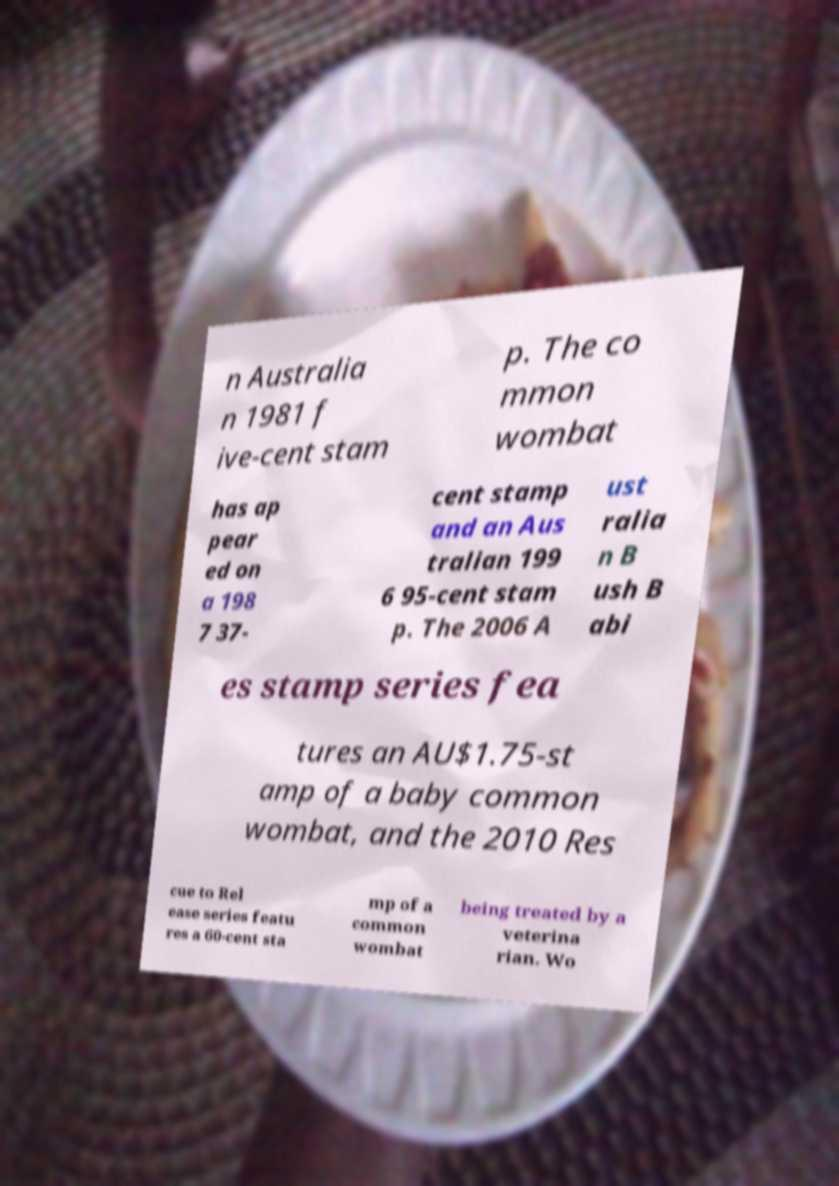Could you assist in decoding the text presented in this image and type it out clearly? n Australia n 1981 f ive-cent stam p. The co mmon wombat has ap pear ed on a 198 7 37- cent stamp and an Aus tralian 199 6 95-cent stam p. The 2006 A ust ralia n B ush B abi es stamp series fea tures an AU$1.75-st amp of a baby common wombat, and the 2010 Res cue to Rel ease series featu res a 60-cent sta mp of a common wombat being treated by a veterina rian. Wo 